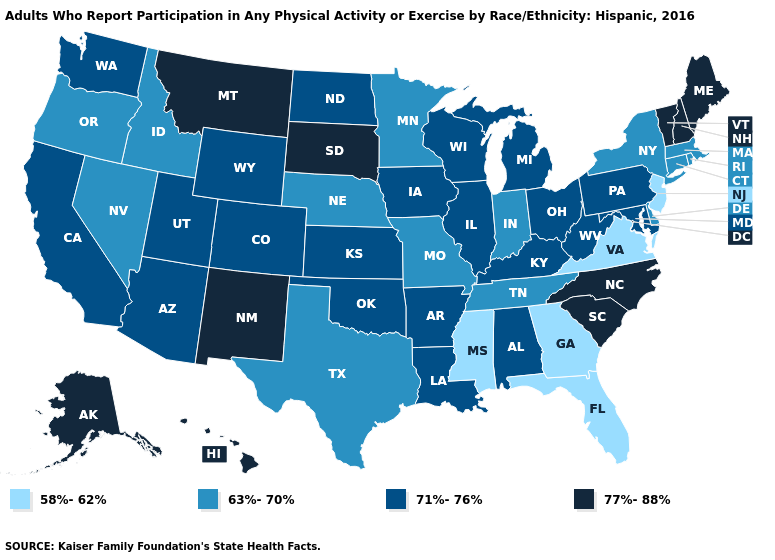Name the states that have a value in the range 58%-62%?
Keep it brief. Florida, Georgia, Mississippi, New Jersey, Virginia. What is the highest value in the USA?
Short answer required. 77%-88%. What is the value of Arkansas?
Write a very short answer. 71%-76%. What is the lowest value in states that border New Jersey?
Write a very short answer. 63%-70%. Name the states that have a value in the range 71%-76%?
Quick response, please. Alabama, Arizona, Arkansas, California, Colorado, Illinois, Iowa, Kansas, Kentucky, Louisiana, Maryland, Michigan, North Dakota, Ohio, Oklahoma, Pennsylvania, Utah, Washington, West Virginia, Wisconsin, Wyoming. Which states have the lowest value in the USA?
Short answer required. Florida, Georgia, Mississippi, New Jersey, Virginia. Name the states that have a value in the range 71%-76%?
Concise answer only. Alabama, Arizona, Arkansas, California, Colorado, Illinois, Iowa, Kansas, Kentucky, Louisiana, Maryland, Michigan, North Dakota, Ohio, Oklahoma, Pennsylvania, Utah, Washington, West Virginia, Wisconsin, Wyoming. Name the states that have a value in the range 58%-62%?
Quick response, please. Florida, Georgia, Mississippi, New Jersey, Virginia. Which states have the lowest value in the West?
Keep it brief. Idaho, Nevada, Oregon. Name the states that have a value in the range 63%-70%?
Write a very short answer. Connecticut, Delaware, Idaho, Indiana, Massachusetts, Minnesota, Missouri, Nebraska, Nevada, New York, Oregon, Rhode Island, Tennessee, Texas. What is the value of New Mexico?
Write a very short answer. 77%-88%. Among the states that border Michigan , does Ohio have the lowest value?
Give a very brief answer. No. Does Maine have the highest value in the USA?
Short answer required. Yes. Among the states that border Colorado , which have the highest value?
Write a very short answer. New Mexico. What is the lowest value in the South?
Give a very brief answer. 58%-62%. 